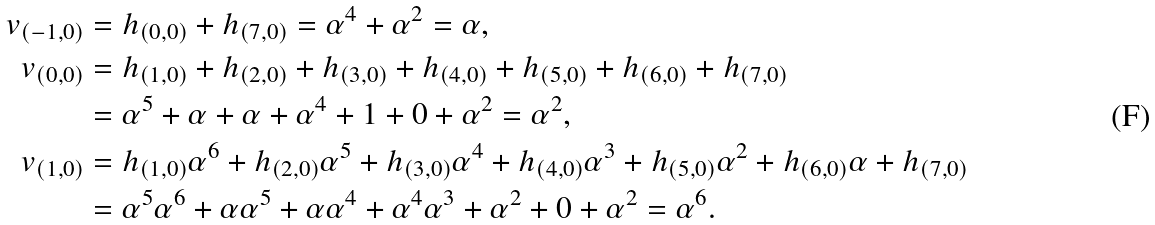Convert formula to latex. <formula><loc_0><loc_0><loc_500><loc_500>v _ { ( - 1 , 0 ) } & = h _ { ( 0 , 0 ) } + h _ { ( 7 , 0 ) } = \alpha ^ { 4 } + \alpha ^ { 2 } = \alpha , \\ v _ { ( 0 , 0 ) } & = h _ { ( 1 , 0 ) } + h _ { ( 2 , 0 ) } + h _ { ( 3 , 0 ) } + h _ { ( 4 , 0 ) } + h _ { ( 5 , 0 ) } + h _ { ( 6 , 0 ) } + h _ { ( 7 , 0 ) } \\ & = \alpha ^ { 5 } + \alpha + \alpha + \alpha ^ { 4 } + 1 + 0 + \alpha ^ { 2 } = \alpha ^ { 2 } , \\ v _ { ( 1 , 0 ) } & = h _ { ( 1 , 0 ) } \alpha ^ { 6 } + h _ { ( 2 , 0 ) } \alpha ^ { 5 } + h _ { ( 3 , 0 ) } \alpha ^ { 4 } + h _ { ( 4 , 0 ) } \alpha ^ { 3 } + h _ { ( 5 , 0 ) } \alpha ^ { 2 } + h _ { ( 6 , 0 ) } \alpha + h _ { ( 7 , 0 ) } \\ & = \alpha ^ { 5 } \alpha ^ { 6 } + \alpha \alpha ^ { 5 } + \alpha \alpha ^ { 4 } + \alpha ^ { 4 } \alpha ^ { 3 } + \alpha ^ { 2 } + 0 + \alpha ^ { 2 } = \alpha ^ { 6 } .</formula> 